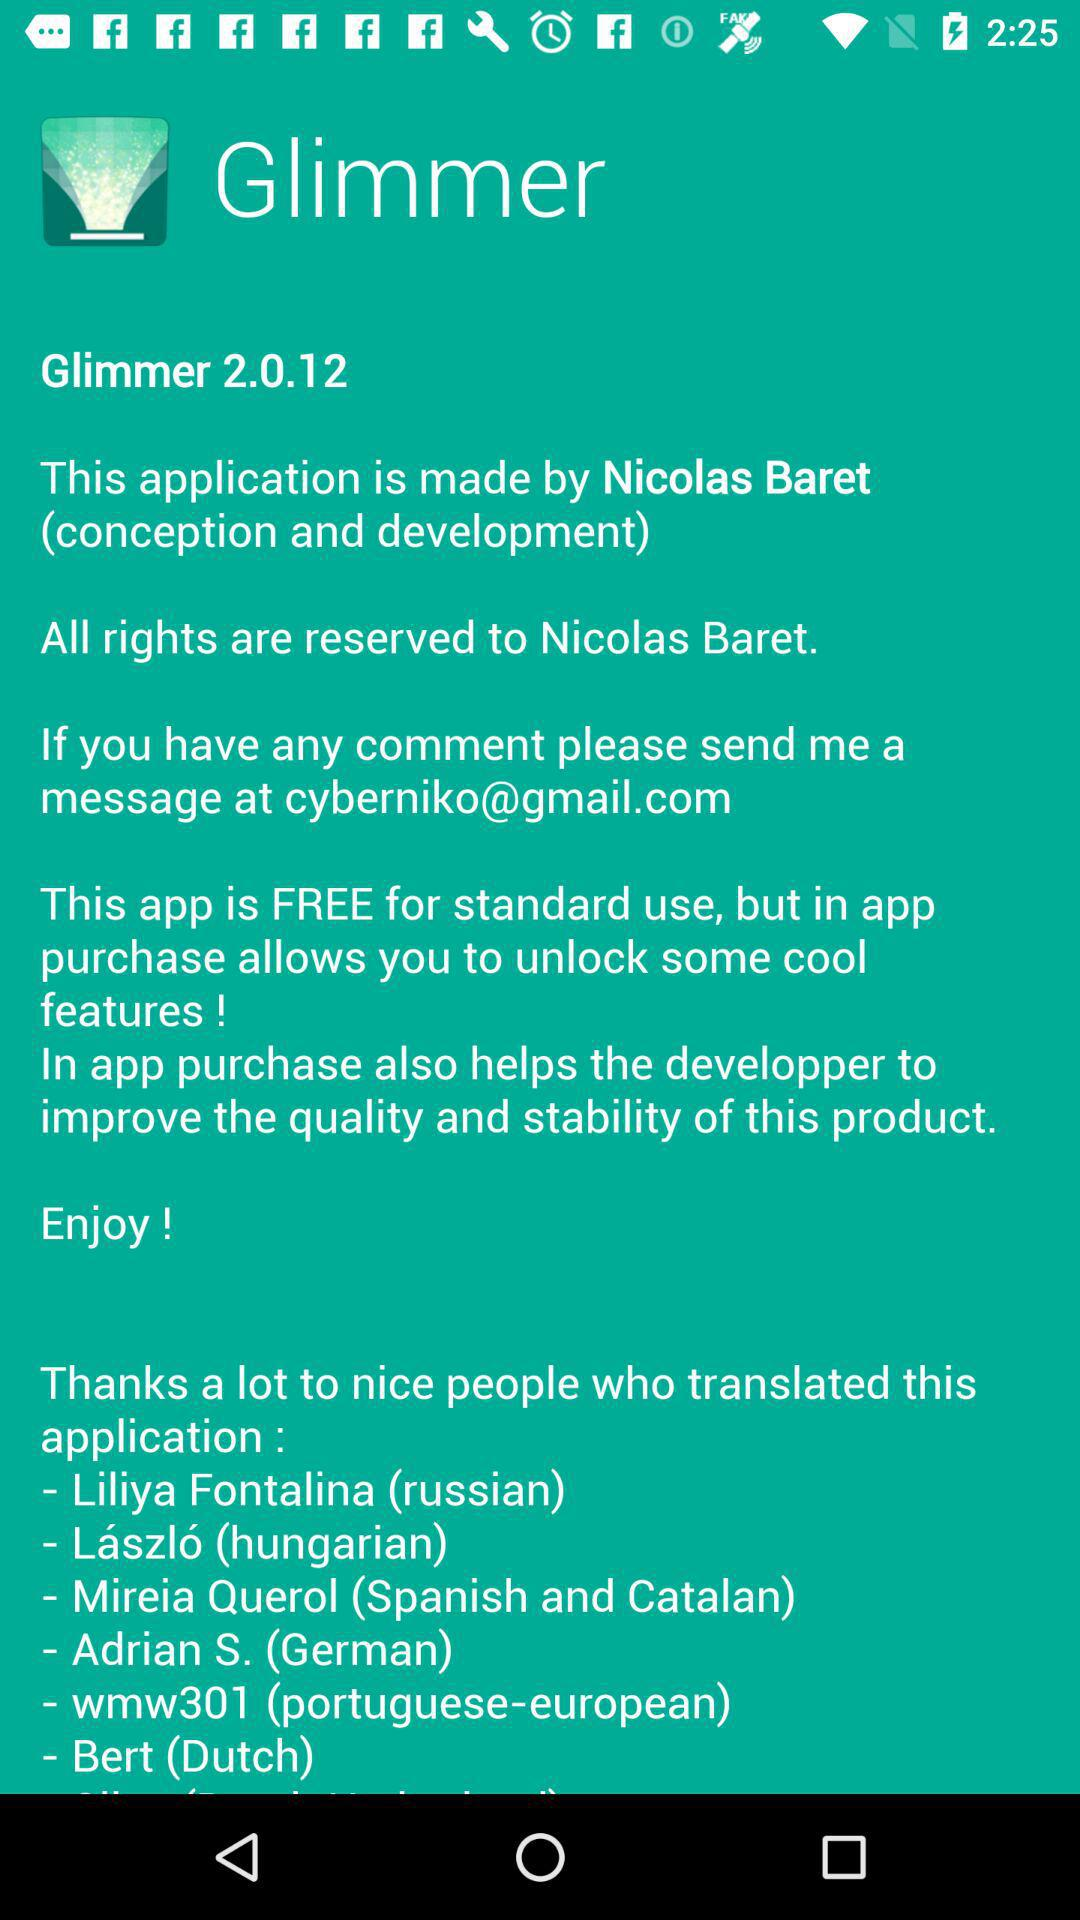Who is the developer of the application? The developer is Nicolas Baret. 